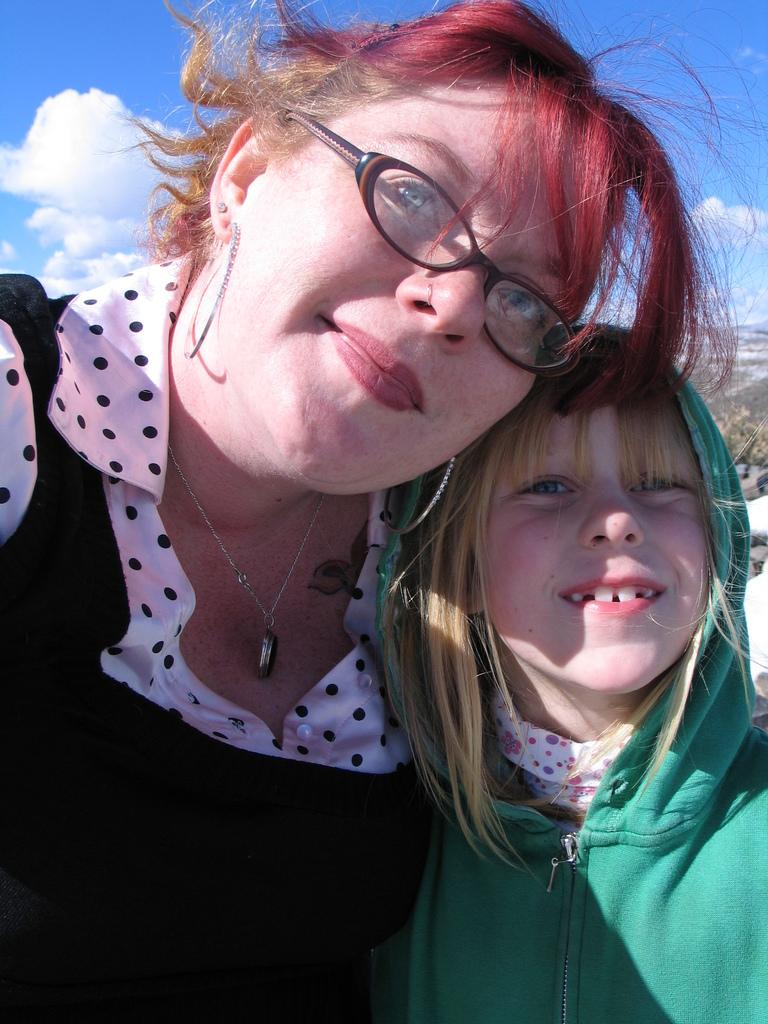How many people are in the image? There are two persons in the image. What expressions do the people have? Both persons are smiling. Can you describe any accessories worn by one of the persons? One person is wearing spectacles. What can be seen in the background of the image? There is sky visible in the background of the image. What direction is the boat sailing in the image? There is no boat present in the image. What type of scale is being used to weigh the objects in the image? There is no scale present in the image. 